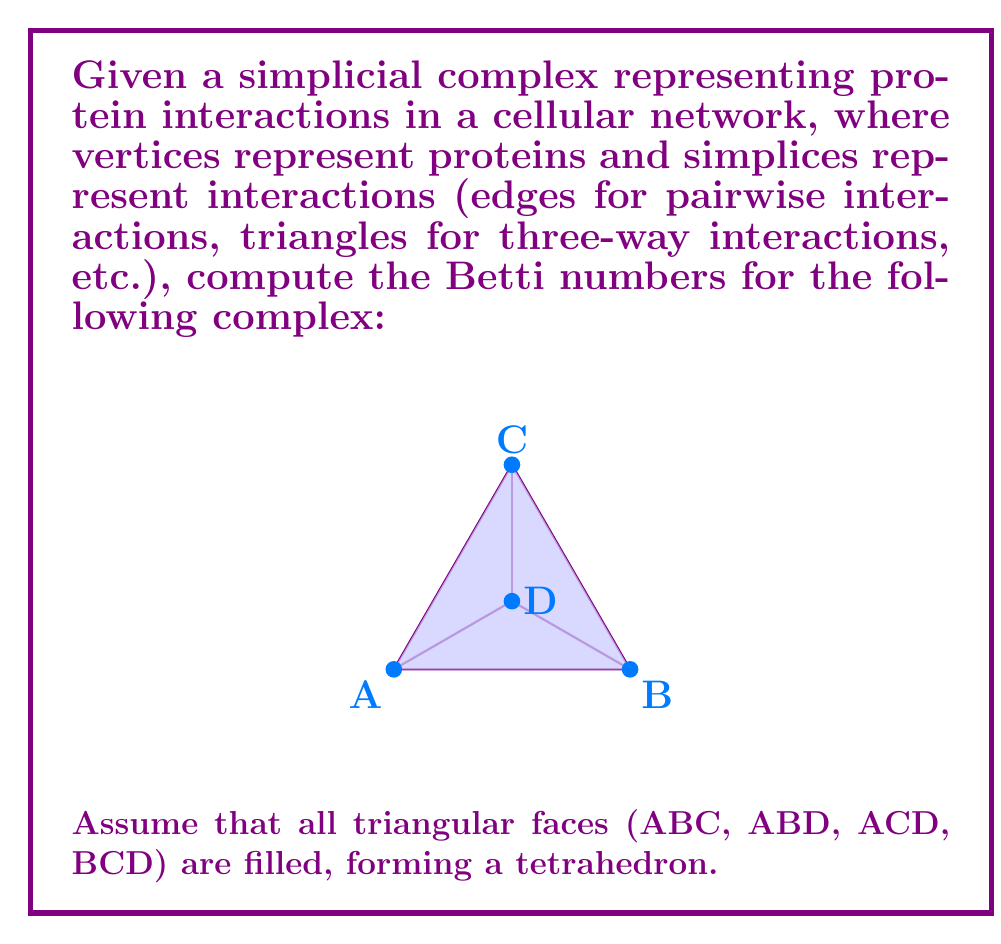Show me your answer to this math problem. To compute the Betti numbers of this simplicial complex, we need to follow these steps:

1. Identify the simplices in each dimension:
   - 0-simplices (vertices): A, B, C, D
   - 1-simplices (edges): AB, AC, AD, BC, BD, CD
   - 2-simplices (triangles): ABC, ABD, ACD, BCD
   - 3-simplices (tetrahedron): ABCD

2. Calculate the number of simplices in each dimension:
   - $n_0 = 4$ (0-simplices)
   - $n_1 = 6$ (1-simplices)
   - $n_2 = 4$ (2-simplices)
   - $n_3 = 1$ (3-simplices)

3. Compute the ranks of the boundary maps:
   - $\text{rank}(\partial_1) = 3$ (number of edges in a spanning tree)
   - $\text{rank}(\partial_2) = 3$ (number of triangles needed to form the surface of the tetrahedron)
   - $\text{rank}(\partial_3) = 1$ (the tetrahedron itself)

4. Calculate the Betti numbers using the formula:
   $$\beta_k = \text{dim}(\text{ker }\partial_k) - \text{rank}(\partial_{k+1})$$

   - $\beta_0 = n_0 - \text{rank}(\partial_1) = 4 - 3 = 1$
   - $\beta_1 = (n_1 - \text{rank}(\partial_1)) - \text{rank}(\partial_2) = (6 - 3) - 3 = 0$
   - $\beta_2 = (n_2 - \text{rank}(\partial_2)) - \text{rank}(\partial_3) = (4 - 3) - 1 = 0$
   - $\beta_3 = n_3 - \text{rank}(\partial_3) = 1 - 1 = 0$

5. Interpret the results:
   - $\beta_0 = 1$ indicates one connected component
   - $\beta_1 = 0$ indicates no 1-dimensional holes (cycles)
   - $\beta_2 = 0$ indicates no 2-dimensional voids
   - $\beta_3 = 0$ is expected for a 3-dimensional object
Answer: $\beta_0 = 1, \beta_1 = 0, \beta_2 = 0, \beta_3 = 0$ 